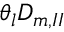<formula> <loc_0><loc_0><loc_500><loc_500>\theta _ { l } D _ { m , I I }</formula> 